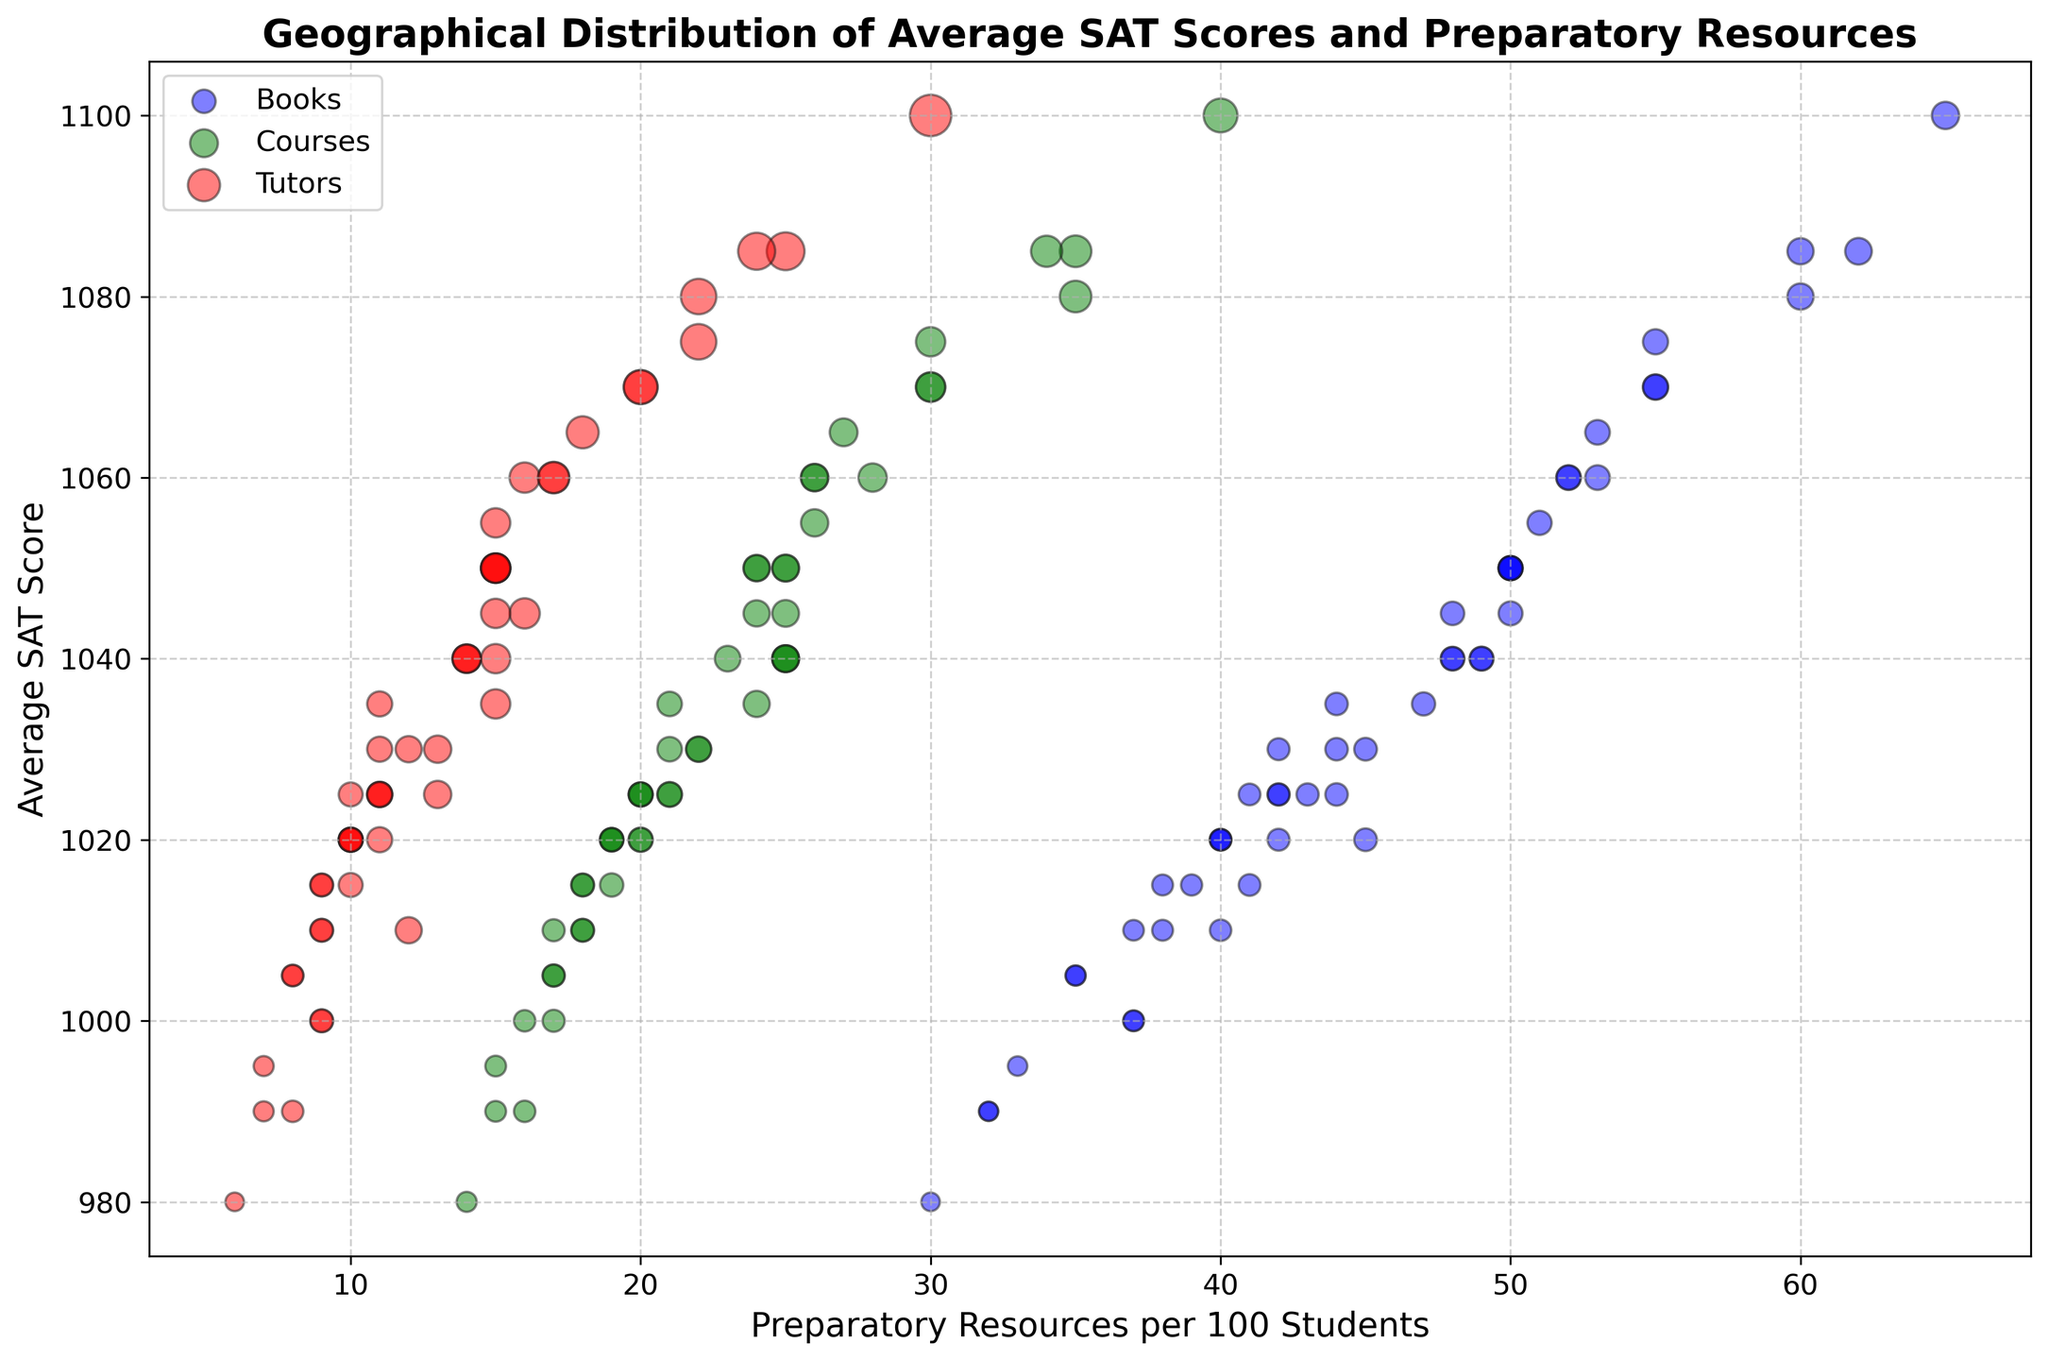What state's average SAT score is highest, and how many preparatory courses per 100 students does that state have? Massachusetts has the highest average SAT score of 1100, and it has 40 preparatory courses per 100 students. To find this, look for the data point with the highest y-axis value, which corresponds to Massachusetts. Then, trace vertically to see the number of prep courses.
Answer: Massachusetts, 40 Which states have more than 50 preparatory books per 100 students, and what are their average SAT scores? The states with more than 50 prep books per 100 students are New York, New Jersey, Massachusetts, Maryland, Connecticut, and District of Columbia. Their average SAT scores are 1070, 1080, 1100, 1075, 1085, and 1085, respectively. To answer this, identify the data points with x-values (prep books) greater than 50 and note their y-values (average SAT scores).
Answer: New York: 1070, New Jersey: 1080, Massachusetts: 1100, Maryland: 1075, Connecticut: 1085, District of Columbia: 1085 What color represents the data points for prep courses, and how can you identify the prep course data visually? The green color represents prep courses. Prep course data points can be identified by finding the green scatter points and noting their locations on the x-axis (prep courses) and y-axis (average SAT score).
Answer: green How does the availability of tutors per 100 students correlate with the average SAT scores across states? The red data points represent tutors. Generally, states with more tutors per 100 students tend to have higher average SAT scores. This can be observed by looking at the trend of red points increasing along the y-axis (average SAT score).
Answer: Positive correlation Which state has the lowest number of preparatory books per 100 students, and what is its average SAT score? The state with the lowest number of prep books per 100 students is Mississippi, with 30 prep books per 100 students and an average SAT score of 980. Identify the data point with the smallest x-axis value and check its corresponding y-axis value.
Answer: Mississippi, 980 Compare the states with the highest and lowest number of tutors per 100 students. What are their average SAT scores and which states are they? The state with the highest number of tutors per 100 students is Massachusetts (30 tutors, average SAT score: 1100). The state with the lowest number is Mississippi (6 tutors, average SAT score: 980). Find the data points with the highest and lowest x-axis values (tutors) and their corresponding y-axis values (average SAT scores).
Answer: Massachusetts: 1100, Mississippi: 980 What is the average number of preparatory books per 100 students for states with an average SAT score greater than 1050? States with average SAT scores greater than 1050 are New York, Pennsylvania, New Jersey, Massachusetts, Virginia, Washington, Maryland, Connecticut, Vermont, and District of Columbia. Add their prep books per 100 students (55 + 53 + 60 + 65 + 52 + 51 + 55 + 60 + 55 + 62) = 518. Divide by 10 states to get the average: 518 / 10 = 51.8.
Answer: 51.8 